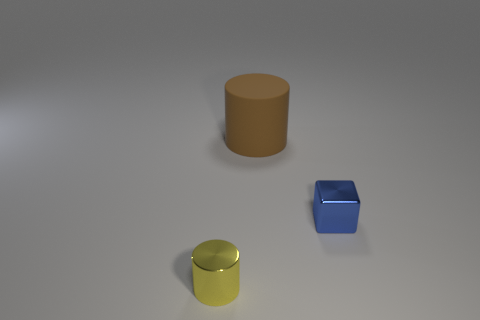There is a blue block that is the same size as the yellow cylinder; what is its material?
Ensure brevity in your answer.  Metal. What is the color of the small shiny cylinder?
Keep it short and to the point. Yellow. What is the thing that is behind the yellow metal cylinder and to the left of the blue metallic cube made of?
Offer a very short reply. Rubber. There is a tiny thing that is behind the cylinder that is in front of the tiny blue shiny cube; are there any small blue metallic objects in front of it?
Your response must be concise. No. There is a brown cylinder; are there any yellow objects behind it?
Your answer should be compact. No. What number of other things are the same shape as the brown matte object?
Ensure brevity in your answer.  1. There is a cylinder that is the same size as the blue thing; what is its color?
Offer a very short reply. Yellow. Is the number of small yellow shiny objects behind the small yellow metallic cylinder less than the number of matte cylinders that are left of the large cylinder?
Your answer should be compact. No. What number of small cubes are to the left of the cylinder that is in front of the shiny thing that is behind the yellow metal cylinder?
Keep it short and to the point. 0. The brown thing that is the same shape as the yellow thing is what size?
Give a very brief answer. Large. 